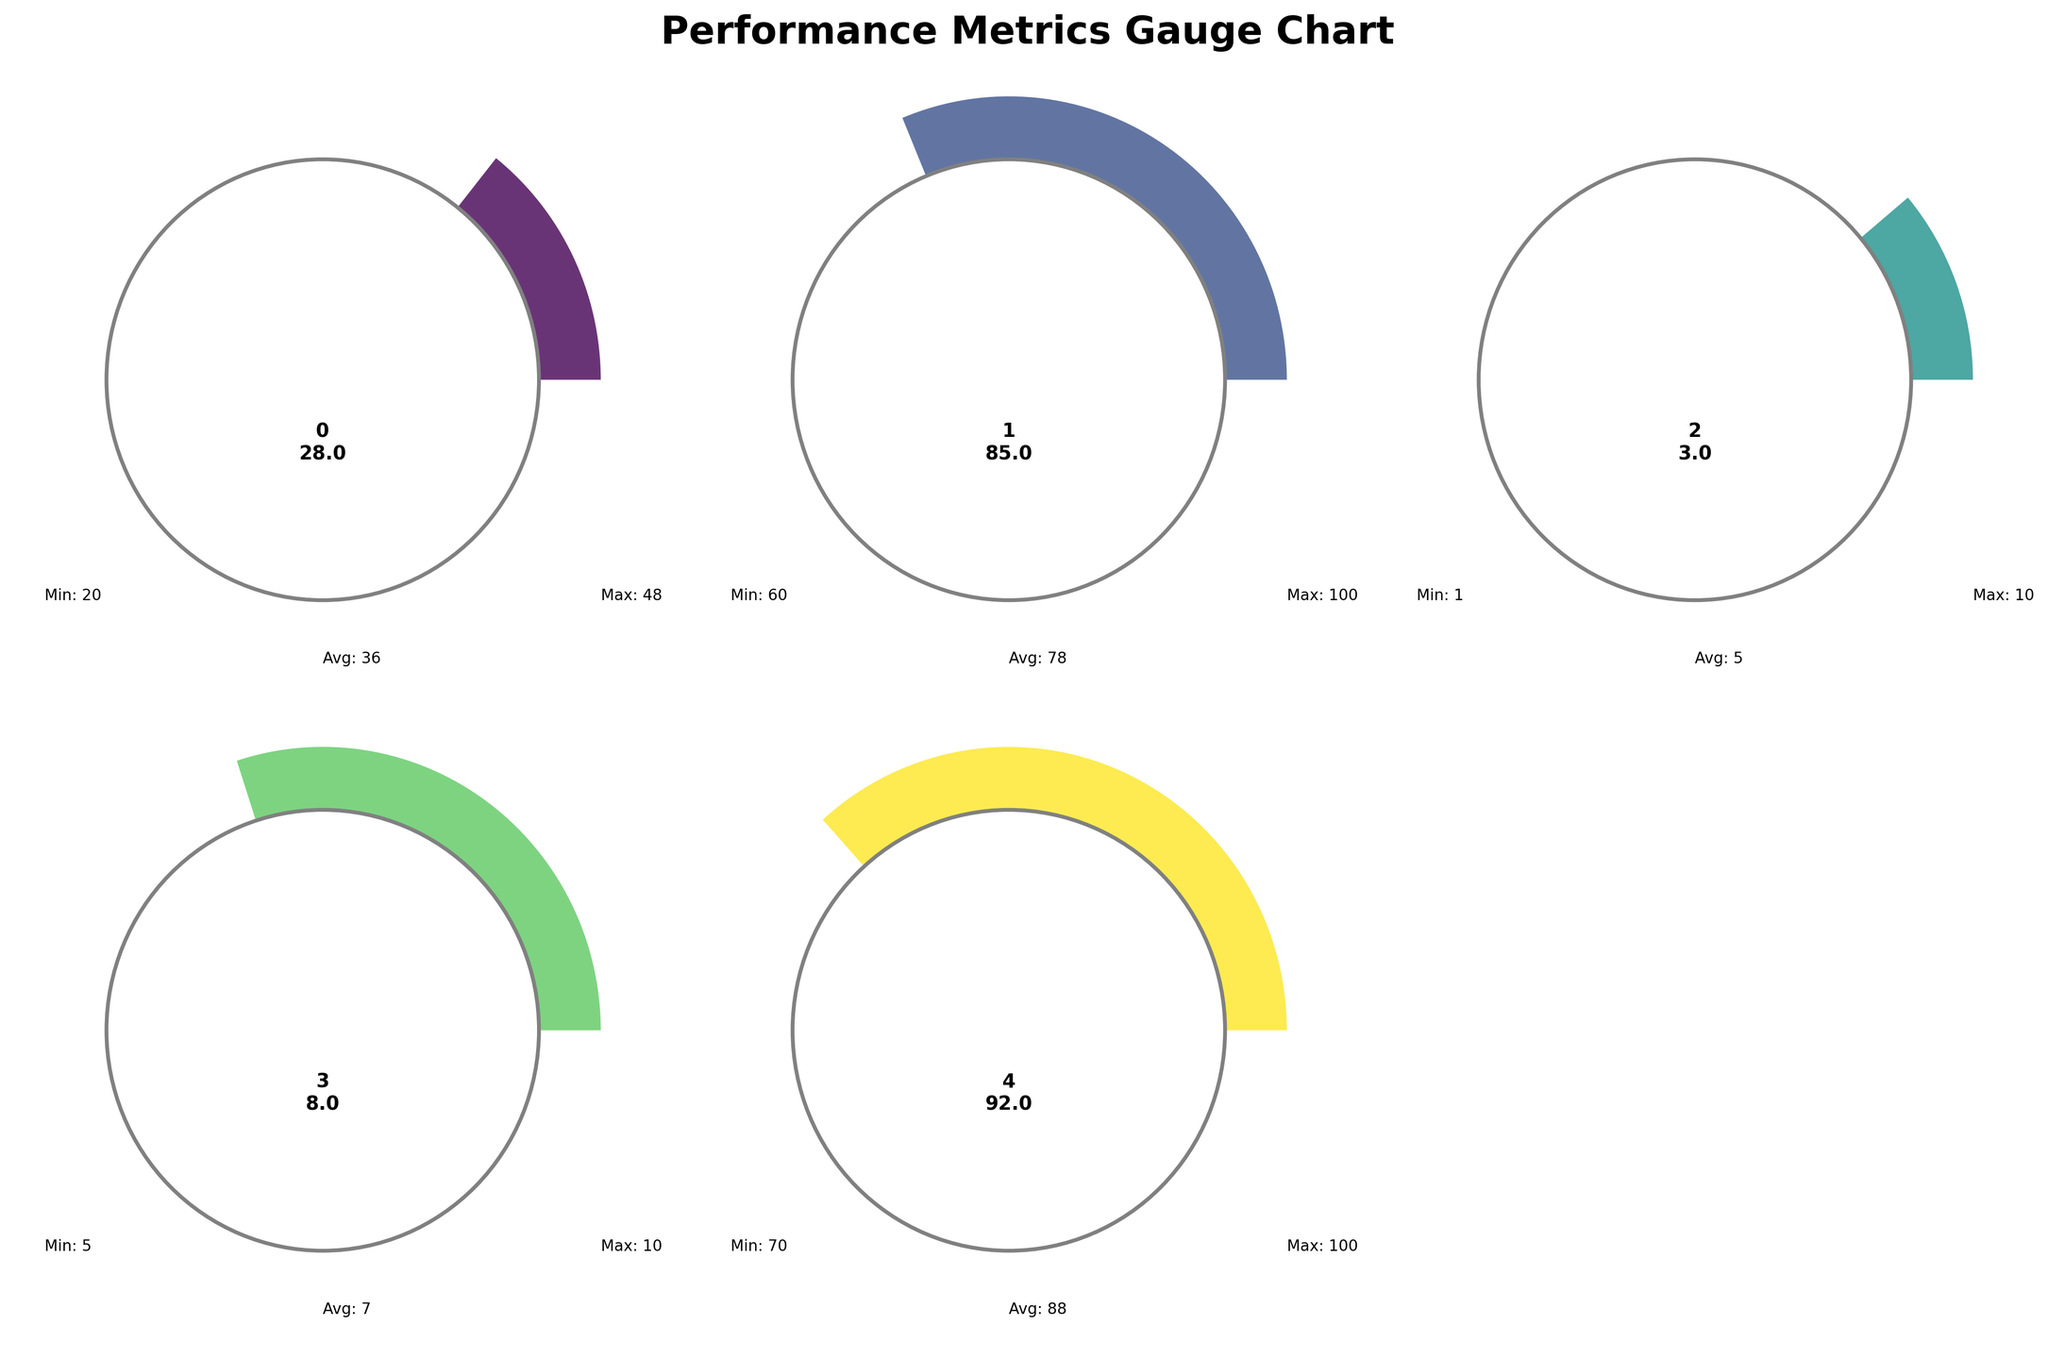What is the current recovery time after intense training sessions? The recovery time is displayed on the gauge chart for "Recovery time (hours)" in the figure, which shows a value of 28 hours.
Answer: 28 hours What metric has the highest current score? By comparing the "current" values for each metric in the figure, the highest value is Flexibility score with 85.
Answer: Flexibility score What is the average flexibility score? The average value for the flexibility score is displayed as part of the gauge chart labeled "Flexibility score," showing a value of 78.
Answer: 78 How does the current recovery time compare to the average recovery time? The current recovery time is 28 hours while the average recovery time is shown as 36 hours on the gauge chart, indicating the current time is lower.
Answer: Lower Is the current sleep quality above or below the average sleep quality? The current sleep quality is shown as 8, while the average is shown as 7, which means the current sleep quality is above average.
Answer: Above What's the difference between the current and average soreness levels? The current soreness level is 3 and the average is 5, so the difference is 5 - 3 = 2.
Answer: 2 Which metric's current value is closest to its average? Comparing the current and average values for all metrics, the sleep quality (Current: 8, Average: 7) has the smallest difference of 1.
Answer: Sleep quality What is the range of hydration levels displayed on the gauge chart? The minimum hydration level is 70% and the maximum is 100%, so the range is 100 - 70 = 30%.
Answer: 30% Is the current flexibility score above the average flexibility score? The flexibility score's current value is 85, while the average value is 78, indicating the current score is above the average.
Answer: Above Between recovery time and sleep quality, which metric has improved more compared to their average values? Recovery time's average is 36, and current is 28, improvement of 36 - 28 = 8. Sleep quality's average is 7, and current is 8, improvement of 8 - 7 = 1. Thus, recovery time has improved more by 8 hours.
Answer: Recovery time 